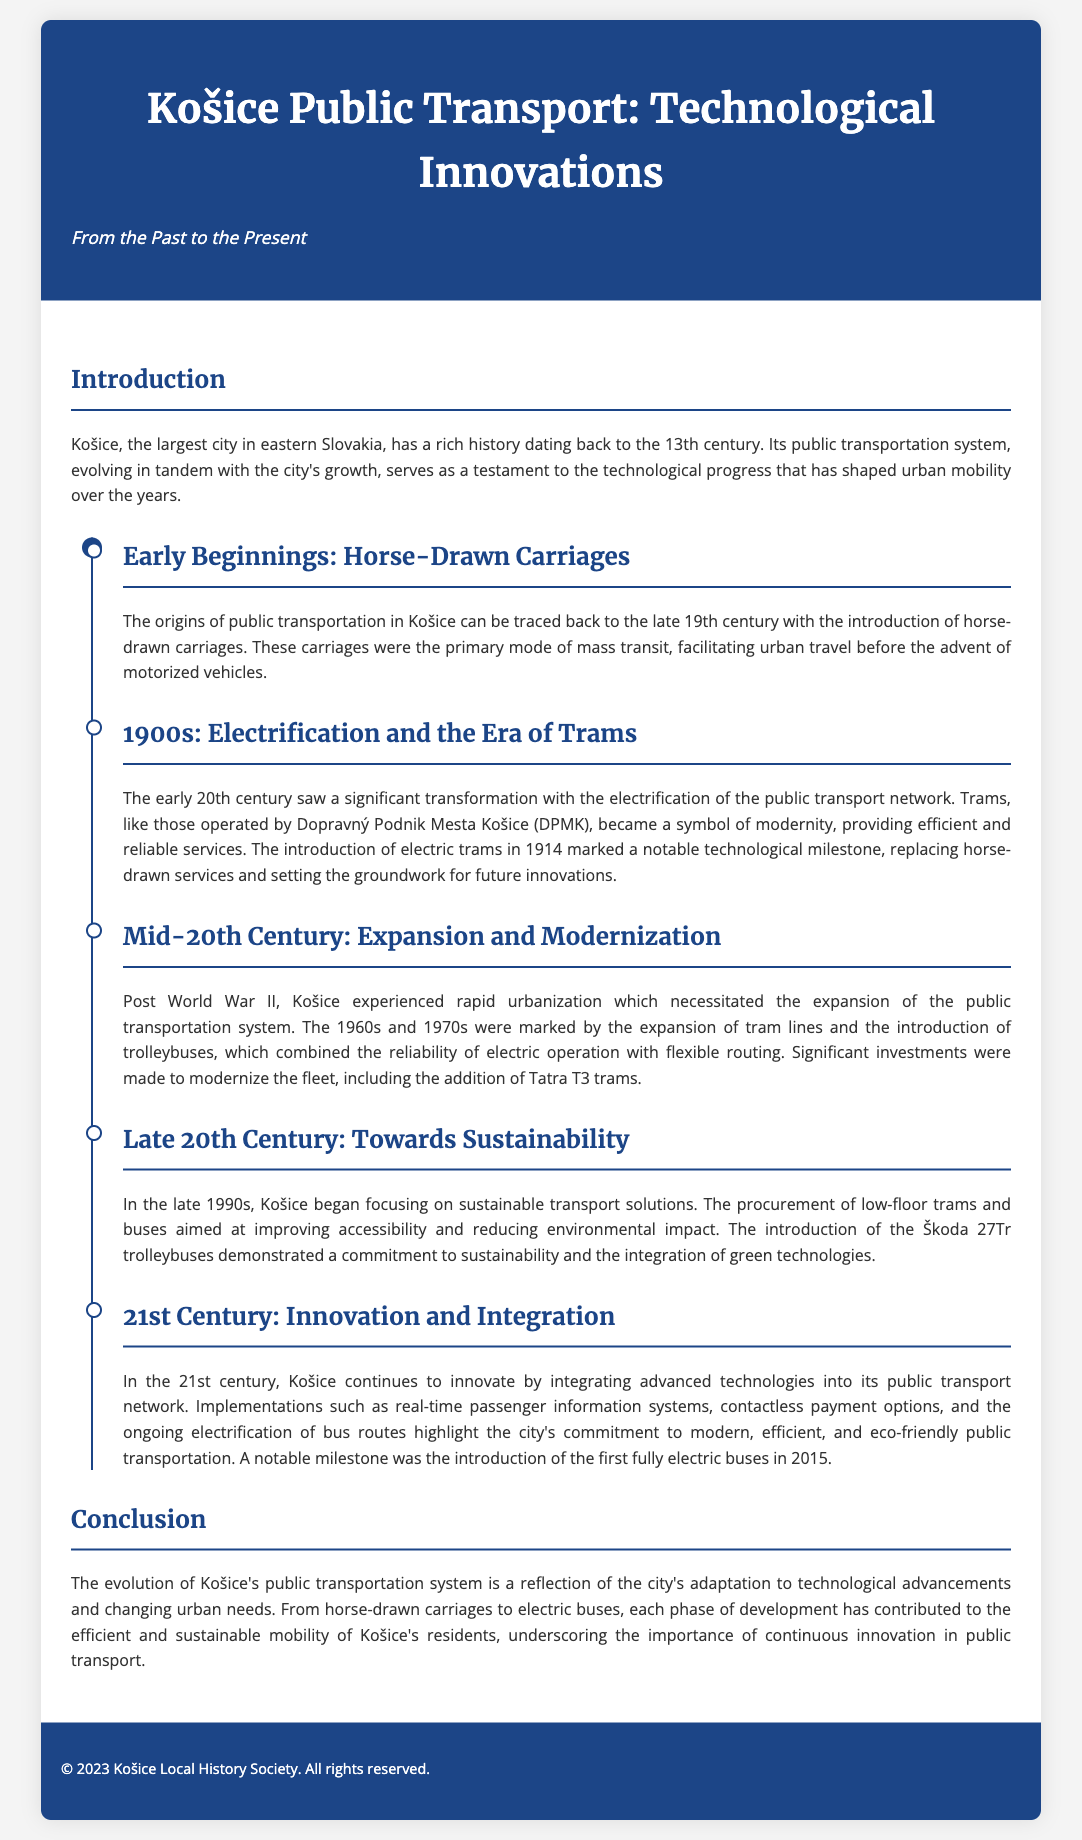What symbol of modernity emerged in the early 20th century? The introduction of electric trams in 1914 marked a notable technological milestone, symbolizing modernity in the public transport network.
Answer: electric trams When did Košice begin focusing on sustainable transport solutions? The late 1990s marked the period when Košice started to focus on sustainable transport solutions, as stated in the document.
Answer: late 1990s What type of trams were introduced in the mid-20th century? During the mid-20th century, significant investments were made to modernize the fleet, including the addition of Tatra T3 trams.
Answer: Tatra T3 trams What was a notable milestone in public transport in Košice in 2015? The document mentions that a notable milestone was the introduction of the first fully electric buses in 2015.
Answer: first fully electric buses What transportation mode preceded electric tram systems? The origins of public transportation in Košice can be traced back to horse-drawn carriages before the advent of motorized vehicles.
Answer: horse-drawn carriages What major transportation advancement occurred in 1914? The early 20th century saw the electrification of the public transport network, specifically with the introduction of electric trams in 1914.
Answer: electric trams What two transport systems were combined in the late 20th century? The introduction of low-floor trams and buses aimed at improving accessibility and reducing environmental impact combined reliability with a focus on sustainability.
Answer: trams and buses What city does the whitepaper focus on? The document discusses public transport technological innovations specifically in Košice, Slovakia.
Answer: Košice 